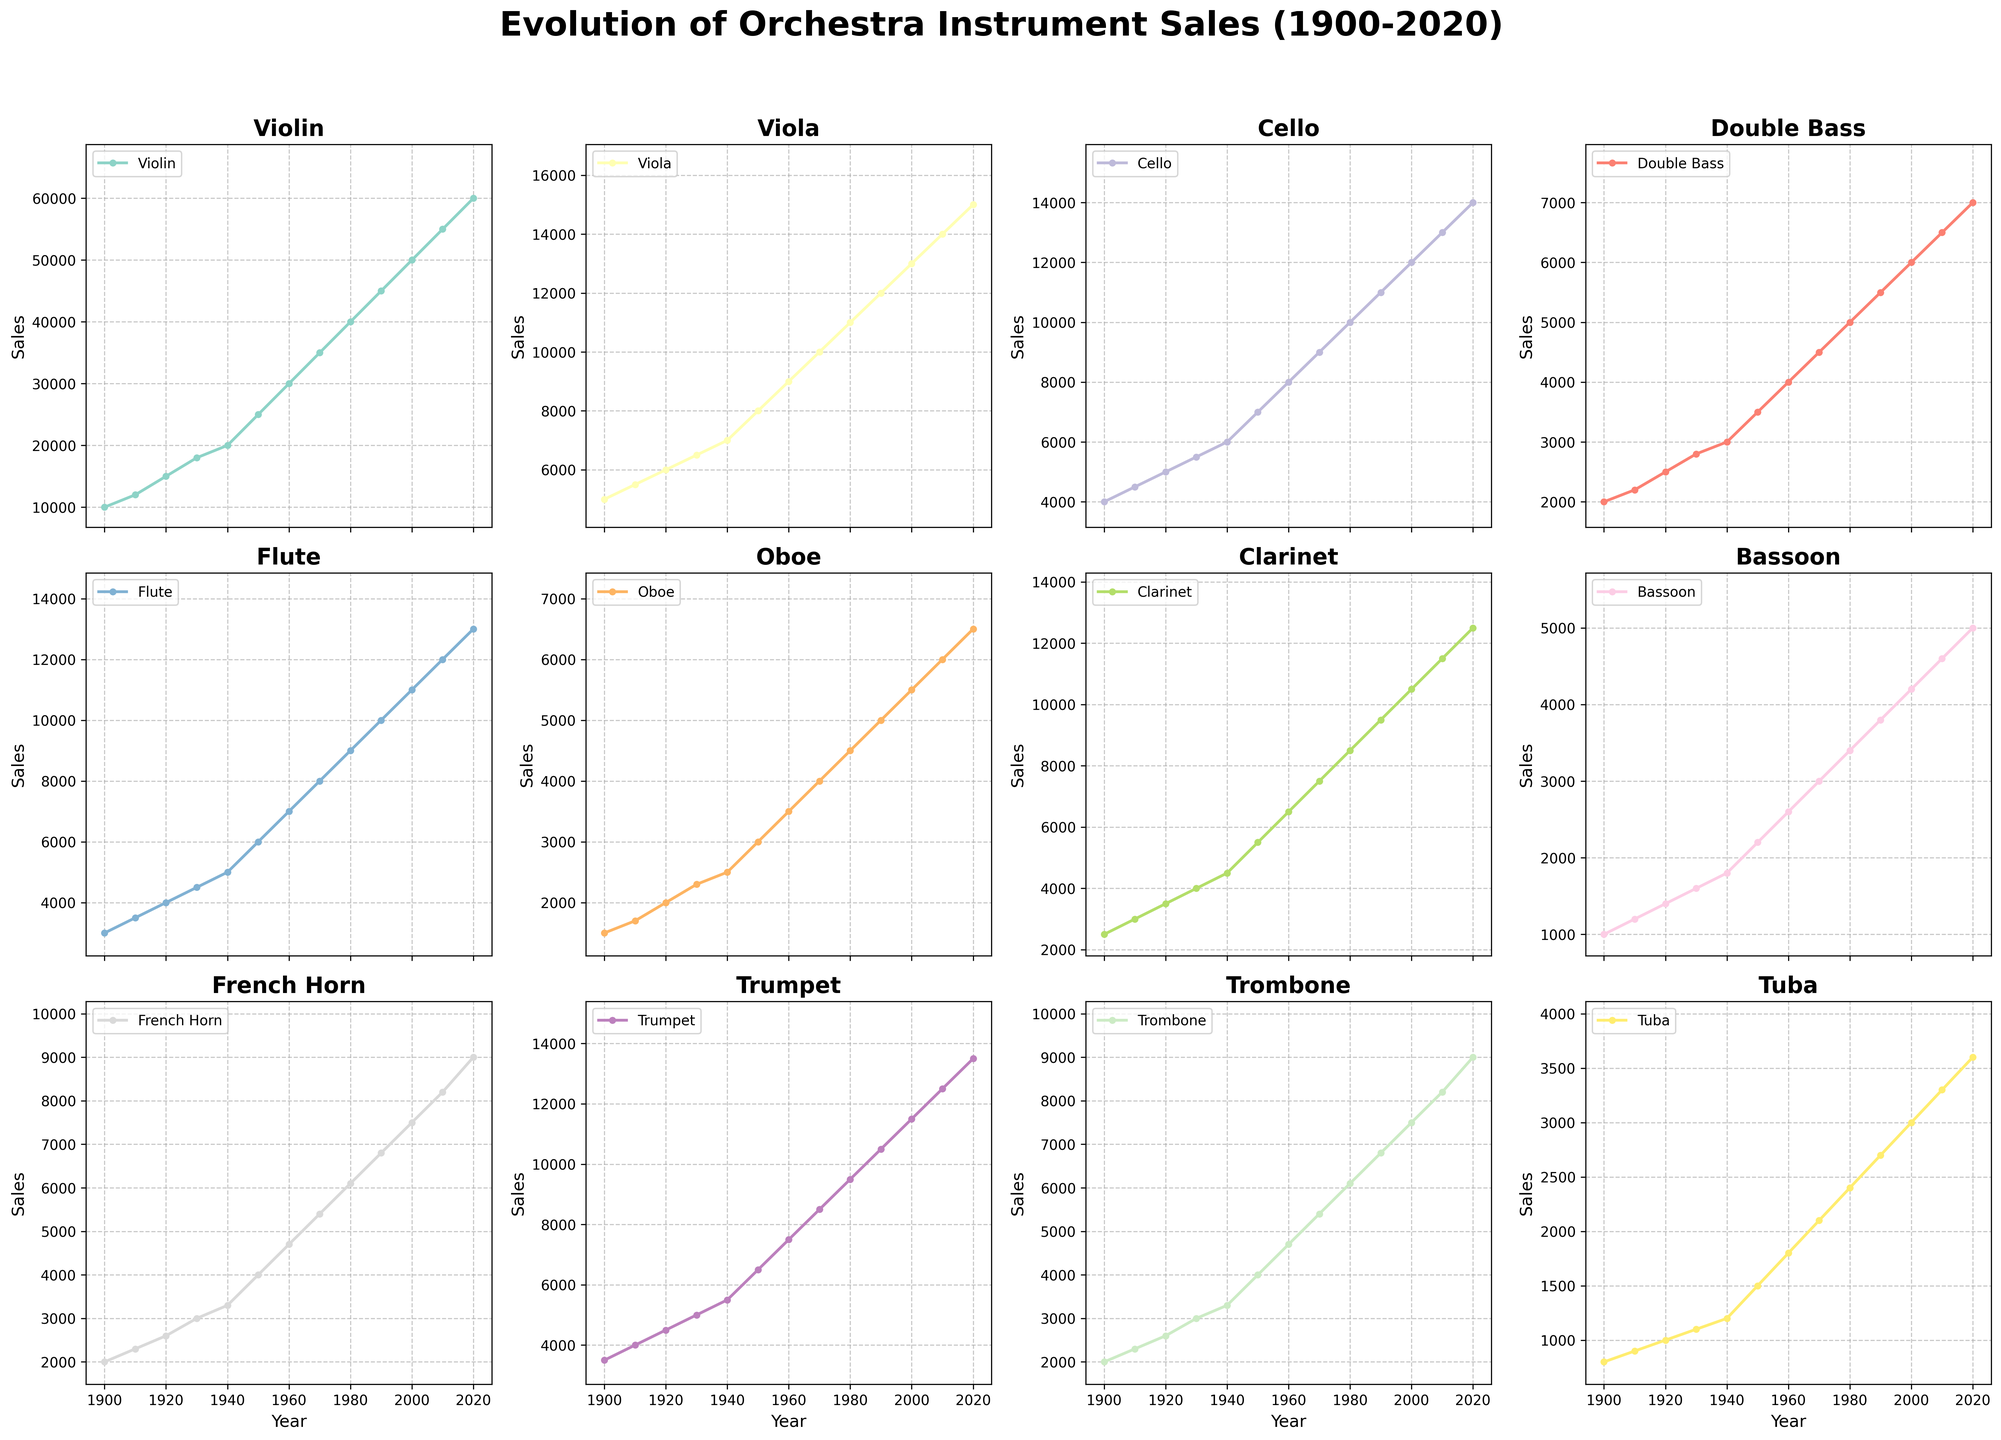Which instrument had the highest sales in 2020? To find this, look at the rightmost data points of all subplots, which represent the sales figures for 2020. Identify the highest value among these points.
Answer: Violin How did the sales of Trombones and Tuba compare in 1950? Locate the year 1950 on the x-axis in the subplots for Trombone and Tuba. Compare the y-axis values at this year. Trombone sales are 4000, and Tuba sales are 1500.
Answer: Trombone sales were higher What was the average sales growth of the Double Bass from 1900 to 2020? Calculate the difference in sales from 1900 to 2020 (7000 - 2000 = 5000) and then divide by the number of years (2020 - 1900 = 120). Thus, the average sales growth is 5000/120.
Answer: 41.67 Which instrument showed the most steady increase in sales over the years? Review the slopes and smoothness of the lines in all subplots. The one with the most consistent upward trend will be the answer.
Answer: Violin Between 1940 and 1960, which wind instrument showed the greatest increase in sales? Compare the sales increase of all wind instruments (Flute, Oboe, Clarinet, Bassoon, French Horn, Trumpet, Trombone, Tuba) from 1940 to 1960 by finding the difference between their 1960 and 1940 values. For example, Flute: 7000-5000=2000, Oboe: 3500-2500=1000, etc.
Answer: Flute What year did Viola sales surpass 10,000? Identify the first year on the x-axis of the Viola subplot where the y-axis value exceeds 10,000.
Answer: 1970 Which instrument sales tripled from 1900 to 2000? Check if any instrument’s sales in 2000 are roughly three times their sales in 1900 by dividing the 2000 value by the 1900 value. For example, Violin: 50000/10000 = 5, Viola: 13000/5000 = 2.6, etc.
Answer: Cello How do the sales trends of the Flute and the Clarinet compare over the entire period? Observe the overall slopes of the lines in both subplots. Both instruments show an upward trend, but with different rates of increase and sporadic variations.
Answer: Both increased with variations What is the difference in sales between French Horn and Trumpet in 2020? Find the sales values for French Horn and Trumpet in 2020 and subtract one from the other. French Horn: 9000, Trumpet: 13500, so 13500 - 9000.
Answer: 4500 What was the rate of change in sales for the Violin between 2000 and 2020? Calculate the difference in sales between 2000 and 2020 (60000 - 50000 = 10000) and divide by the number of years (20). The rate of change is 10000/20.
Answer: 500 